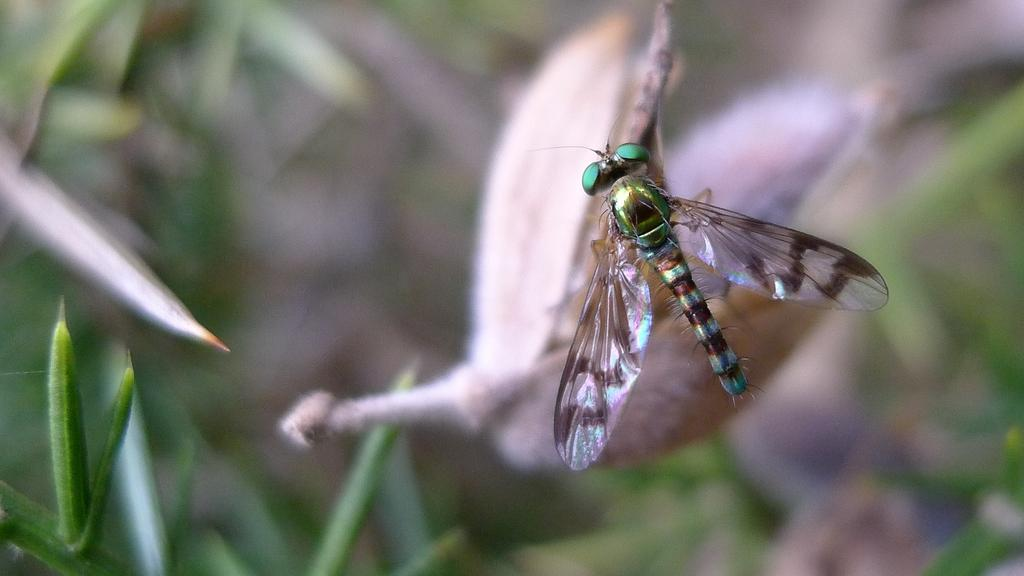What is the image focused on? The image is zoomed in. What insect can be seen on the right side of the image? There is a fly or grasshopper on the right side of the image. How would you describe the background of the image? The background of the image is blurry. What type of vegetation can be seen in the background? There are plants visible in the background of the image. How many ants are carrying a rifle in the image? There are no ants or rifles present in the image. What type of birds can be seen flying in the background of the image? There are no birds visible in the image; only a fly or grasshopper and plants are present in the background. 